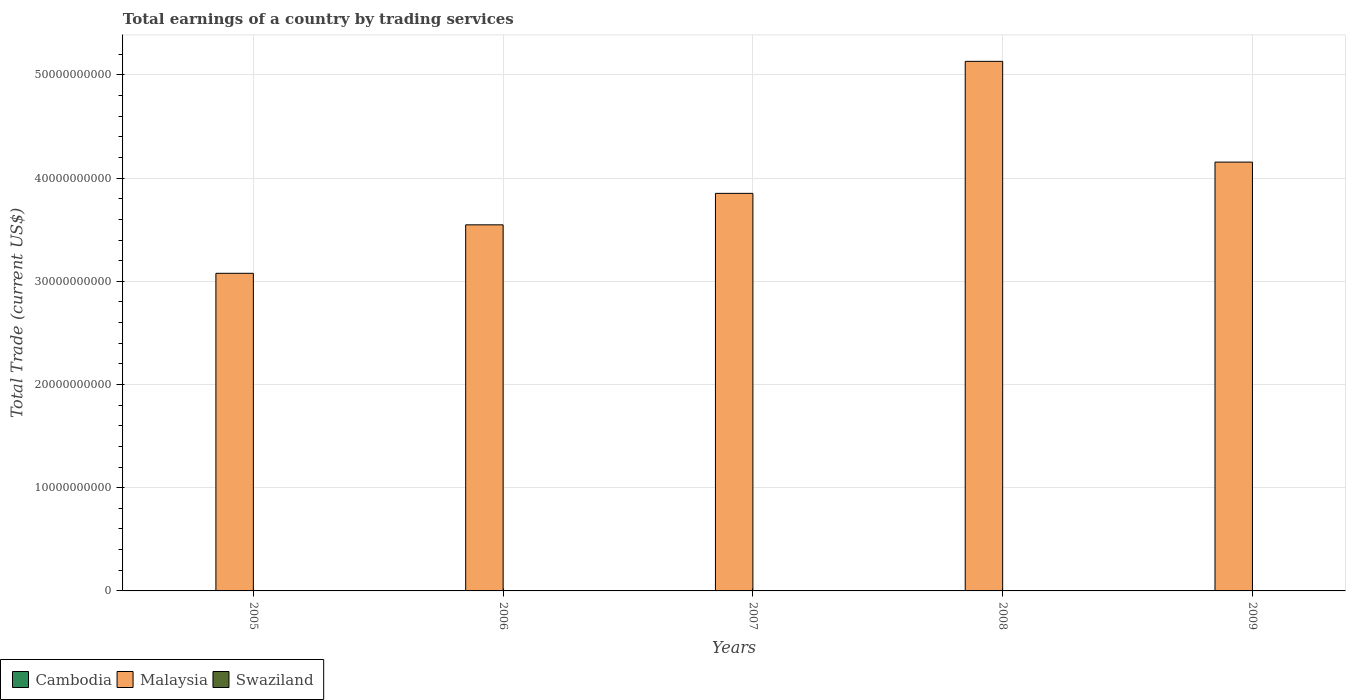Are the number of bars per tick equal to the number of legend labels?
Your response must be concise. No. Are the number of bars on each tick of the X-axis equal?
Keep it short and to the point. Yes. How many bars are there on the 5th tick from the right?
Your response must be concise. 1. What is the total earnings in Cambodia in 2006?
Your answer should be very brief. 0. Across all years, what is the maximum total earnings in Malaysia?
Keep it short and to the point. 5.13e+1. Across all years, what is the minimum total earnings in Swaziland?
Keep it short and to the point. 0. In which year was the total earnings in Malaysia maximum?
Your answer should be very brief. 2008. What is the total total earnings in Swaziland in the graph?
Keep it short and to the point. 0. What is the difference between the total earnings in Malaysia in 2005 and that in 2009?
Your response must be concise. -1.08e+1. What is the difference between the total earnings in Malaysia in 2008 and the total earnings in Swaziland in 2007?
Your answer should be very brief. 5.13e+1. In how many years, is the total earnings in Swaziland greater than 18000000000 US$?
Your response must be concise. 0. What is the ratio of the total earnings in Malaysia in 2008 to that in 2009?
Ensure brevity in your answer.  1.23. What is the difference between the highest and the second highest total earnings in Malaysia?
Make the answer very short. 9.76e+09. In how many years, is the total earnings in Malaysia greater than the average total earnings in Malaysia taken over all years?
Provide a short and direct response. 2. Are all the bars in the graph horizontal?
Provide a succinct answer. No. Are the values on the major ticks of Y-axis written in scientific E-notation?
Offer a very short reply. No. Does the graph contain any zero values?
Your answer should be compact. Yes. How are the legend labels stacked?
Provide a short and direct response. Horizontal. What is the title of the graph?
Provide a succinct answer. Total earnings of a country by trading services. Does "St. Vincent and the Grenadines" appear as one of the legend labels in the graph?
Provide a succinct answer. No. What is the label or title of the Y-axis?
Offer a very short reply. Total Trade (current US$). What is the Total Trade (current US$) in Cambodia in 2005?
Your answer should be very brief. 0. What is the Total Trade (current US$) in Malaysia in 2005?
Offer a terse response. 3.08e+1. What is the Total Trade (current US$) in Swaziland in 2005?
Ensure brevity in your answer.  0. What is the Total Trade (current US$) in Malaysia in 2006?
Your response must be concise. 3.55e+1. What is the Total Trade (current US$) of Swaziland in 2006?
Offer a terse response. 0. What is the Total Trade (current US$) in Malaysia in 2007?
Your answer should be very brief. 3.85e+1. What is the Total Trade (current US$) in Malaysia in 2008?
Provide a short and direct response. 5.13e+1. What is the Total Trade (current US$) in Swaziland in 2008?
Ensure brevity in your answer.  0. What is the Total Trade (current US$) of Malaysia in 2009?
Provide a short and direct response. 4.16e+1. Across all years, what is the maximum Total Trade (current US$) of Malaysia?
Keep it short and to the point. 5.13e+1. Across all years, what is the minimum Total Trade (current US$) in Malaysia?
Your answer should be very brief. 3.08e+1. What is the total Total Trade (current US$) in Cambodia in the graph?
Provide a short and direct response. 0. What is the total Total Trade (current US$) of Malaysia in the graph?
Provide a succinct answer. 1.98e+11. What is the total Total Trade (current US$) in Swaziland in the graph?
Your answer should be very brief. 0. What is the difference between the Total Trade (current US$) in Malaysia in 2005 and that in 2006?
Your answer should be very brief. -4.70e+09. What is the difference between the Total Trade (current US$) of Malaysia in 2005 and that in 2007?
Give a very brief answer. -7.74e+09. What is the difference between the Total Trade (current US$) in Malaysia in 2005 and that in 2008?
Your answer should be compact. -2.05e+1. What is the difference between the Total Trade (current US$) in Malaysia in 2005 and that in 2009?
Ensure brevity in your answer.  -1.08e+1. What is the difference between the Total Trade (current US$) in Malaysia in 2006 and that in 2007?
Make the answer very short. -3.05e+09. What is the difference between the Total Trade (current US$) of Malaysia in 2006 and that in 2008?
Provide a succinct answer. -1.58e+1. What is the difference between the Total Trade (current US$) of Malaysia in 2006 and that in 2009?
Make the answer very short. -6.08e+09. What is the difference between the Total Trade (current US$) in Malaysia in 2007 and that in 2008?
Your answer should be compact. -1.28e+1. What is the difference between the Total Trade (current US$) in Malaysia in 2007 and that in 2009?
Give a very brief answer. -3.03e+09. What is the difference between the Total Trade (current US$) in Malaysia in 2008 and that in 2009?
Your response must be concise. 9.76e+09. What is the average Total Trade (current US$) of Malaysia per year?
Make the answer very short. 3.95e+1. What is the ratio of the Total Trade (current US$) of Malaysia in 2005 to that in 2006?
Keep it short and to the point. 0.87. What is the ratio of the Total Trade (current US$) in Malaysia in 2005 to that in 2007?
Keep it short and to the point. 0.8. What is the ratio of the Total Trade (current US$) in Malaysia in 2005 to that in 2008?
Ensure brevity in your answer.  0.6. What is the ratio of the Total Trade (current US$) of Malaysia in 2005 to that in 2009?
Make the answer very short. 0.74. What is the ratio of the Total Trade (current US$) in Malaysia in 2006 to that in 2007?
Ensure brevity in your answer.  0.92. What is the ratio of the Total Trade (current US$) in Malaysia in 2006 to that in 2008?
Offer a very short reply. 0.69. What is the ratio of the Total Trade (current US$) in Malaysia in 2006 to that in 2009?
Ensure brevity in your answer.  0.85. What is the ratio of the Total Trade (current US$) in Malaysia in 2007 to that in 2008?
Keep it short and to the point. 0.75. What is the ratio of the Total Trade (current US$) in Malaysia in 2007 to that in 2009?
Make the answer very short. 0.93. What is the ratio of the Total Trade (current US$) of Malaysia in 2008 to that in 2009?
Make the answer very short. 1.23. What is the difference between the highest and the second highest Total Trade (current US$) in Malaysia?
Your answer should be very brief. 9.76e+09. What is the difference between the highest and the lowest Total Trade (current US$) in Malaysia?
Provide a succinct answer. 2.05e+1. 